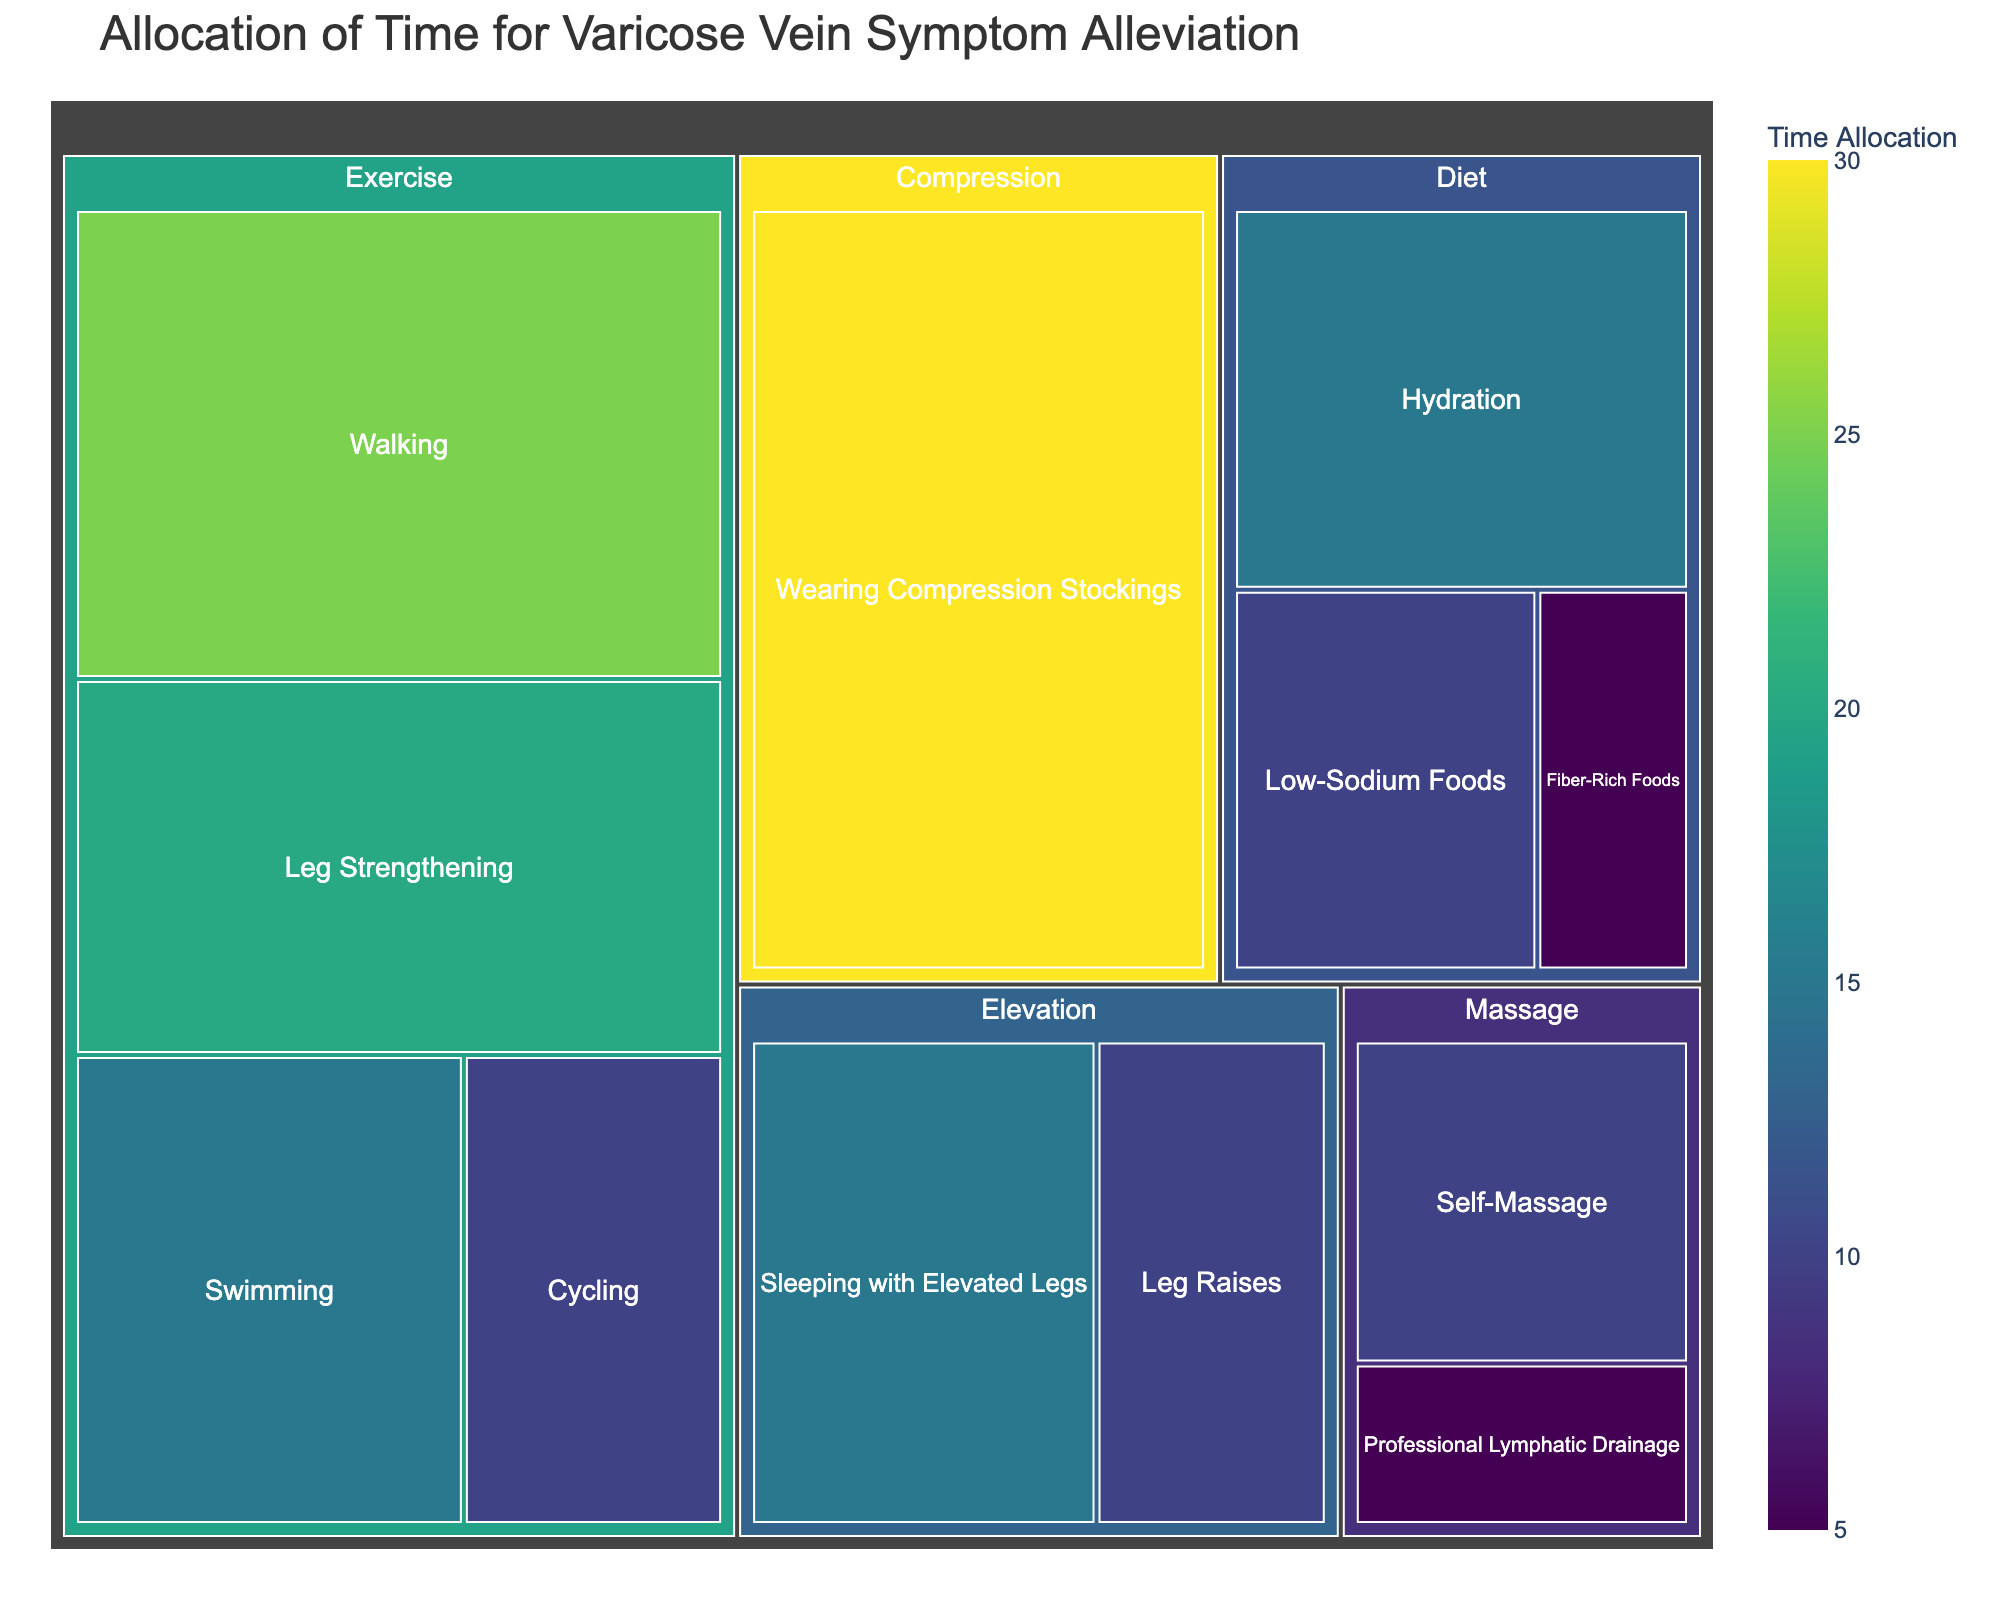What is the title of the figure? The title of the figure is displayed at the top, and it provides an overview of what the chart is about.
Answer: Allocation of Time for Varicose Vein Symptom Alleviation Which subcategory has the highest time allocation? To find the subcategory with the highest time allocation, look for the largest rectangle in the Treemap.
Answer: Wearing Compression Stockings How much total time is allocated for Exercise? Add the time allocations for all the subcategories under Exercise: Walking (25) + Swimming (15) + Cycling (10) + Leg Strengthening (20).
Answer: 70 minutes Which category has more time allotted to it, Diet or Massage? Calculate the total time for each category and compare: Diet (Hydration (15) + Low-Sodium Foods (10) + Fiber-Rich Foods (5)) vs. Massage (Self-Massage (10) + Professional Lymphatic Drainage (5)).
Answer: Diet What is the least time-consuming subcategory? Look for the smallest rectangle in the Treemap, which represents the subcategory with the least time allocation.
Answer: Professional Lymphatic Drainage How many subcategories are present in the Diet category? Count the number of rectangles under the Diet category in the Treemap.
Answer: 3 Which has more time allocated: Leg Strengthening or Swimming plus Leg Raises? Compare the total times by adding: Swimming (15) + Leg Raises (10) = 25, then compare it to Leg Strengthening (20).
Answer: Swimming plus Leg Raises Which category has the smallest total time allocation? Sum the time allocations for each category and identify the one with the smallest sum: Exercise (70), Diet (30), Elevation (25), Compression (30), Massage (15).
Answer: Massage What proportion of time is allocated to Walking out of the total Exercise time? Calculate the proportion: Walking (25) / Total Exercise (70) = 25/70.
Answer: Approximately 35.7% Identify one compositional question you might ask to analyze the elevation methods. Calculate the sum of the time allocations for Leg Raises (10) and Sleeping with Elevated Legs (15).
Answer: 25 minutes 